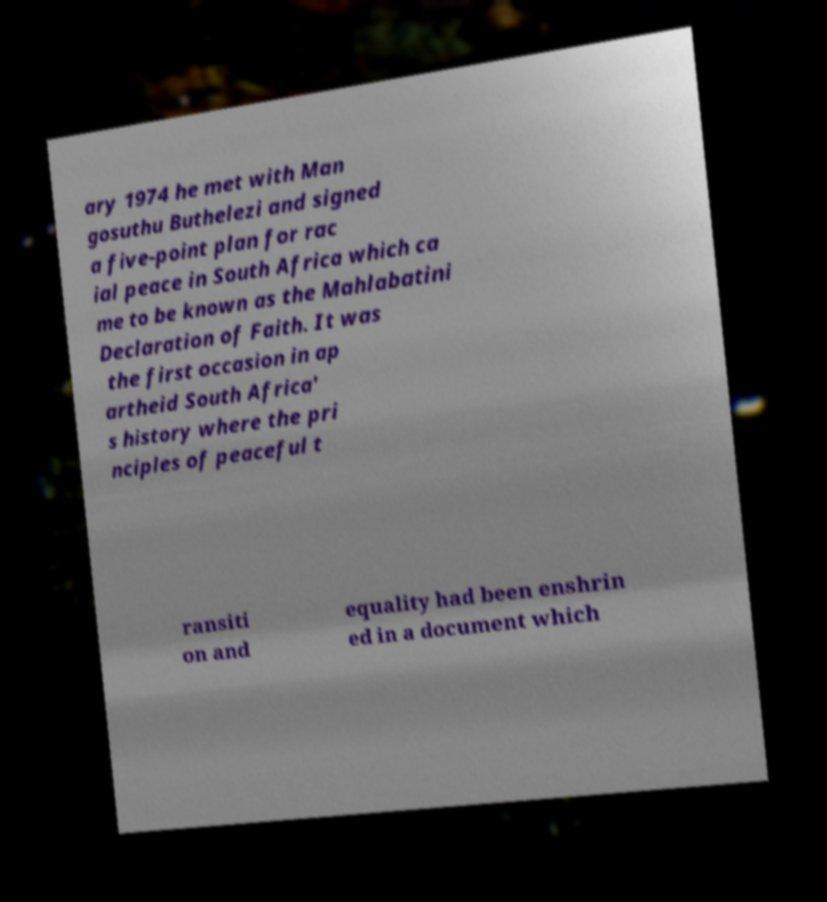There's text embedded in this image that I need extracted. Can you transcribe it verbatim? ary 1974 he met with Man gosuthu Buthelezi and signed a five-point plan for rac ial peace in South Africa which ca me to be known as the Mahlabatini Declaration of Faith. It was the first occasion in ap artheid South Africa' s history where the pri nciples of peaceful t ransiti on and equality had been enshrin ed in a document which 